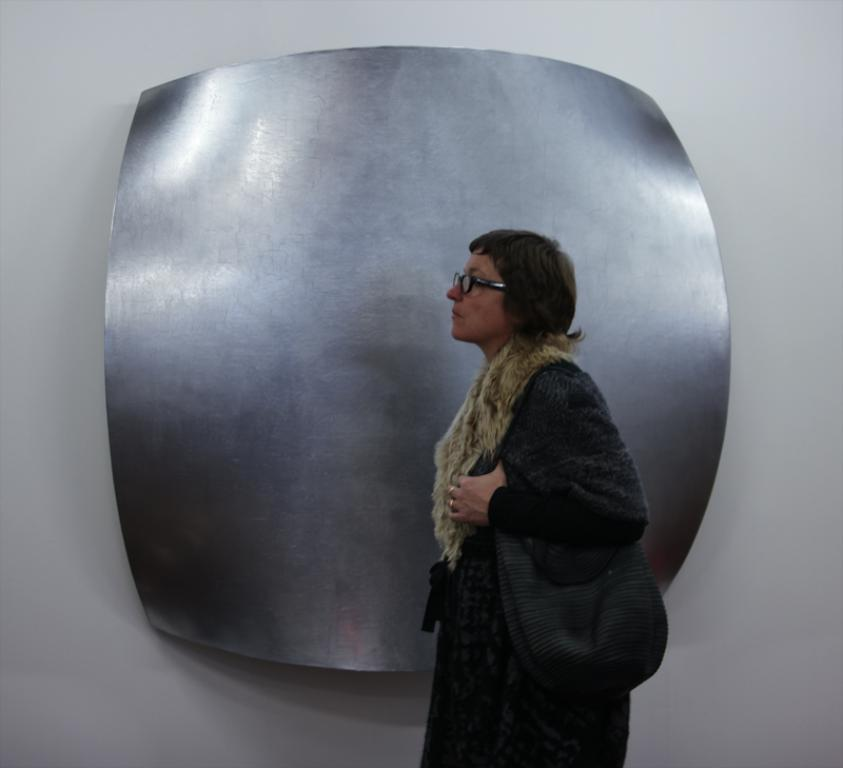Who is present in the image? There is a woman in the image. What is the woman wearing? The woman is wearing a bag and glasses. What can be seen in the background of the image? There is a metal sheet and a white wall in the background of the image. What is the cause of the woman's throne in the image? There is no throne present in the image, so it is not possible to determine the cause. 